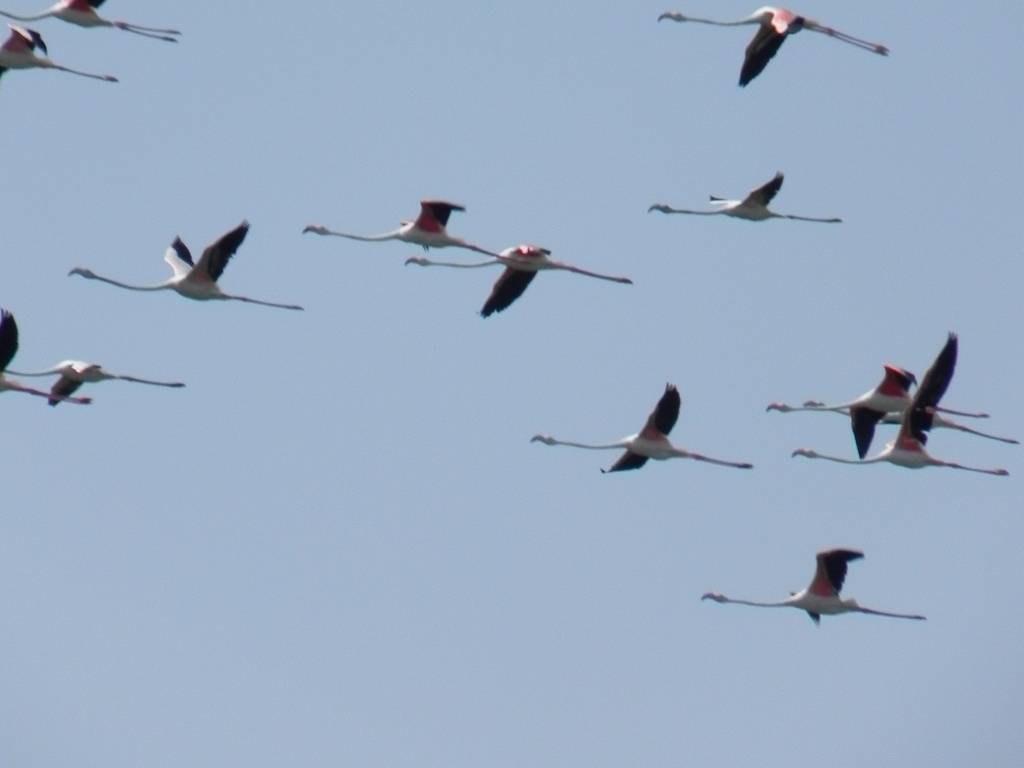Considering the blur and composition, how might a photographer improve a similar shot in the future? To improve clarity in a similar shot, a photographer should use a faster shutter speed to freeze the motion, especially considering the fast movement of flying birds. A higher-resolution camera with a telephoto lens would also help in capturing finer detail. Compositionally, waiting for a moment when the birds are more spread out or positioned against a contrasting background could create a more impactful image. 